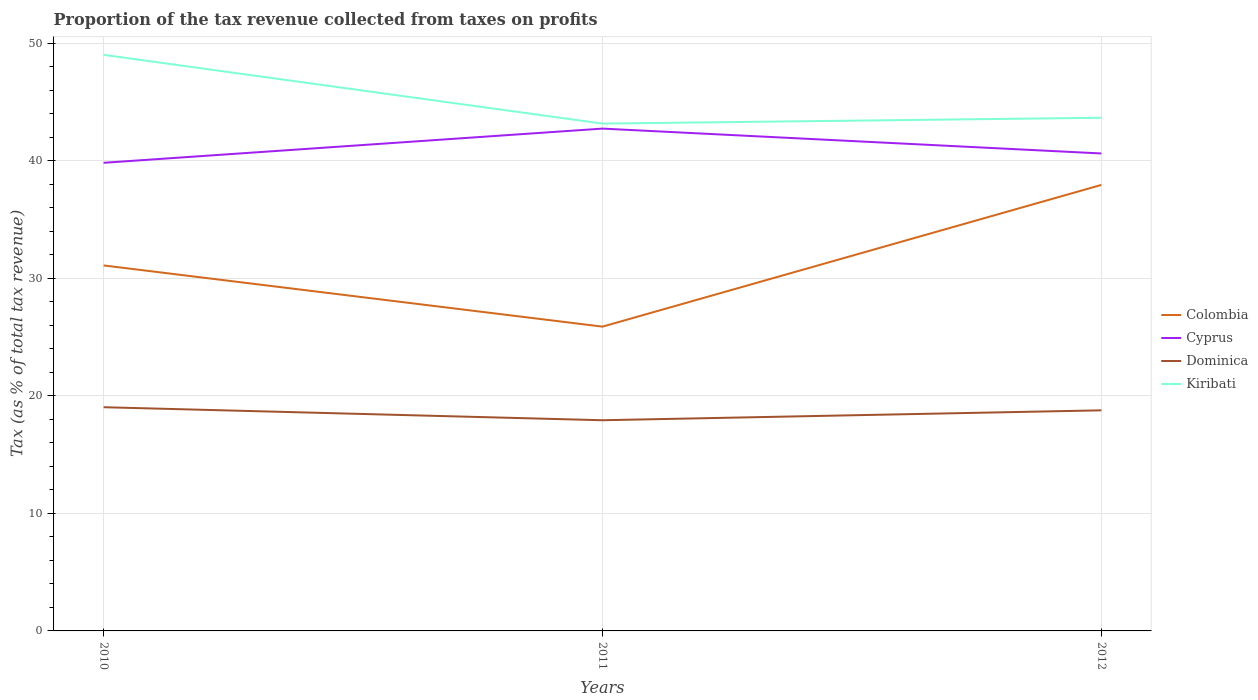Across all years, what is the maximum proportion of the tax revenue collected in Dominica?
Keep it short and to the point. 17.92. What is the total proportion of the tax revenue collected in Colombia in the graph?
Make the answer very short. -6.85. What is the difference between the highest and the second highest proportion of the tax revenue collected in Cyprus?
Give a very brief answer. 2.91. What is the difference between the highest and the lowest proportion of the tax revenue collected in Dominica?
Give a very brief answer. 2. How many years are there in the graph?
Your answer should be very brief. 3. What is the difference between two consecutive major ticks on the Y-axis?
Ensure brevity in your answer.  10. Does the graph contain any zero values?
Keep it short and to the point. No. Does the graph contain grids?
Your response must be concise. Yes. Where does the legend appear in the graph?
Keep it short and to the point. Center right. How many legend labels are there?
Your answer should be compact. 4. What is the title of the graph?
Make the answer very short. Proportion of the tax revenue collected from taxes on profits. What is the label or title of the Y-axis?
Your response must be concise. Tax (as % of total tax revenue). What is the Tax (as % of total tax revenue) of Colombia in 2010?
Offer a very short reply. 31.09. What is the Tax (as % of total tax revenue) of Cyprus in 2010?
Your response must be concise. 39.82. What is the Tax (as % of total tax revenue) in Dominica in 2010?
Your answer should be compact. 19.03. What is the Tax (as % of total tax revenue) in Kiribati in 2010?
Your response must be concise. 49. What is the Tax (as % of total tax revenue) of Colombia in 2011?
Offer a very short reply. 25.88. What is the Tax (as % of total tax revenue) of Cyprus in 2011?
Provide a short and direct response. 42.73. What is the Tax (as % of total tax revenue) in Dominica in 2011?
Offer a terse response. 17.92. What is the Tax (as % of total tax revenue) in Kiribati in 2011?
Provide a succinct answer. 43.16. What is the Tax (as % of total tax revenue) of Colombia in 2012?
Provide a short and direct response. 37.94. What is the Tax (as % of total tax revenue) of Cyprus in 2012?
Keep it short and to the point. 40.61. What is the Tax (as % of total tax revenue) in Dominica in 2012?
Keep it short and to the point. 18.76. What is the Tax (as % of total tax revenue) in Kiribati in 2012?
Your answer should be very brief. 43.65. Across all years, what is the maximum Tax (as % of total tax revenue) in Colombia?
Provide a succinct answer. 37.94. Across all years, what is the maximum Tax (as % of total tax revenue) of Cyprus?
Offer a very short reply. 42.73. Across all years, what is the maximum Tax (as % of total tax revenue) of Dominica?
Your answer should be compact. 19.03. Across all years, what is the maximum Tax (as % of total tax revenue) in Kiribati?
Provide a succinct answer. 49. Across all years, what is the minimum Tax (as % of total tax revenue) in Colombia?
Offer a very short reply. 25.88. Across all years, what is the minimum Tax (as % of total tax revenue) of Cyprus?
Offer a terse response. 39.82. Across all years, what is the minimum Tax (as % of total tax revenue) in Dominica?
Make the answer very short. 17.92. Across all years, what is the minimum Tax (as % of total tax revenue) in Kiribati?
Give a very brief answer. 43.16. What is the total Tax (as % of total tax revenue) of Colombia in the graph?
Offer a very short reply. 94.92. What is the total Tax (as % of total tax revenue) in Cyprus in the graph?
Your answer should be compact. 123.17. What is the total Tax (as % of total tax revenue) in Dominica in the graph?
Your answer should be very brief. 55.72. What is the total Tax (as % of total tax revenue) in Kiribati in the graph?
Your response must be concise. 135.81. What is the difference between the Tax (as % of total tax revenue) of Colombia in 2010 and that in 2011?
Make the answer very short. 5.21. What is the difference between the Tax (as % of total tax revenue) of Cyprus in 2010 and that in 2011?
Provide a succinct answer. -2.91. What is the difference between the Tax (as % of total tax revenue) of Dominica in 2010 and that in 2011?
Make the answer very short. 1.11. What is the difference between the Tax (as % of total tax revenue) in Kiribati in 2010 and that in 2011?
Provide a short and direct response. 5.85. What is the difference between the Tax (as % of total tax revenue) of Colombia in 2010 and that in 2012?
Offer a terse response. -6.85. What is the difference between the Tax (as % of total tax revenue) of Cyprus in 2010 and that in 2012?
Your response must be concise. -0.79. What is the difference between the Tax (as % of total tax revenue) of Dominica in 2010 and that in 2012?
Your answer should be compact. 0.27. What is the difference between the Tax (as % of total tax revenue) in Kiribati in 2010 and that in 2012?
Offer a very short reply. 5.35. What is the difference between the Tax (as % of total tax revenue) of Colombia in 2011 and that in 2012?
Provide a short and direct response. -12.06. What is the difference between the Tax (as % of total tax revenue) in Cyprus in 2011 and that in 2012?
Offer a very short reply. 2.12. What is the difference between the Tax (as % of total tax revenue) of Dominica in 2011 and that in 2012?
Your response must be concise. -0.84. What is the difference between the Tax (as % of total tax revenue) in Kiribati in 2011 and that in 2012?
Your response must be concise. -0.5. What is the difference between the Tax (as % of total tax revenue) in Colombia in 2010 and the Tax (as % of total tax revenue) in Cyprus in 2011?
Your answer should be compact. -11.64. What is the difference between the Tax (as % of total tax revenue) of Colombia in 2010 and the Tax (as % of total tax revenue) of Dominica in 2011?
Offer a terse response. 13.17. What is the difference between the Tax (as % of total tax revenue) of Colombia in 2010 and the Tax (as % of total tax revenue) of Kiribati in 2011?
Your answer should be compact. -12.07. What is the difference between the Tax (as % of total tax revenue) in Cyprus in 2010 and the Tax (as % of total tax revenue) in Dominica in 2011?
Your answer should be compact. 21.9. What is the difference between the Tax (as % of total tax revenue) of Cyprus in 2010 and the Tax (as % of total tax revenue) of Kiribati in 2011?
Give a very brief answer. -3.34. What is the difference between the Tax (as % of total tax revenue) in Dominica in 2010 and the Tax (as % of total tax revenue) in Kiribati in 2011?
Make the answer very short. -24.13. What is the difference between the Tax (as % of total tax revenue) in Colombia in 2010 and the Tax (as % of total tax revenue) in Cyprus in 2012?
Your answer should be very brief. -9.52. What is the difference between the Tax (as % of total tax revenue) of Colombia in 2010 and the Tax (as % of total tax revenue) of Dominica in 2012?
Your response must be concise. 12.33. What is the difference between the Tax (as % of total tax revenue) in Colombia in 2010 and the Tax (as % of total tax revenue) in Kiribati in 2012?
Make the answer very short. -12.56. What is the difference between the Tax (as % of total tax revenue) in Cyprus in 2010 and the Tax (as % of total tax revenue) in Dominica in 2012?
Keep it short and to the point. 21.06. What is the difference between the Tax (as % of total tax revenue) of Cyprus in 2010 and the Tax (as % of total tax revenue) of Kiribati in 2012?
Give a very brief answer. -3.83. What is the difference between the Tax (as % of total tax revenue) in Dominica in 2010 and the Tax (as % of total tax revenue) in Kiribati in 2012?
Your response must be concise. -24.62. What is the difference between the Tax (as % of total tax revenue) in Colombia in 2011 and the Tax (as % of total tax revenue) in Cyprus in 2012?
Provide a short and direct response. -14.73. What is the difference between the Tax (as % of total tax revenue) in Colombia in 2011 and the Tax (as % of total tax revenue) in Dominica in 2012?
Your response must be concise. 7.12. What is the difference between the Tax (as % of total tax revenue) in Colombia in 2011 and the Tax (as % of total tax revenue) in Kiribati in 2012?
Your response must be concise. -17.77. What is the difference between the Tax (as % of total tax revenue) of Cyprus in 2011 and the Tax (as % of total tax revenue) of Dominica in 2012?
Your answer should be compact. 23.97. What is the difference between the Tax (as % of total tax revenue) of Cyprus in 2011 and the Tax (as % of total tax revenue) of Kiribati in 2012?
Ensure brevity in your answer.  -0.92. What is the difference between the Tax (as % of total tax revenue) in Dominica in 2011 and the Tax (as % of total tax revenue) in Kiribati in 2012?
Ensure brevity in your answer.  -25.73. What is the average Tax (as % of total tax revenue) in Colombia per year?
Keep it short and to the point. 31.64. What is the average Tax (as % of total tax revenue) in Cyprus per year?
Your answer should be very brief. 41.06. What is the average Tax (as % of total tax revenue) in Dominica per year?
Give a very brief answer. 18.57. What is the average Tax (as % of total tax revenue) of Kiribati per year?
Your answer should be very brief. 45.27. In the year 2010, what is the difference between the Tax (as % of total tax revenue) in Colombia and Tax (as % of total tax revenue) in Cyprus?
Your answer should be very brief. -8.73. In the year 2010, what is the difference between the Tax (as % of total tax revenue) in Colombia and Tax (as % of total tax revenue) in Dominica?
Your answer should be compact. 12.06. In the year 2010, what is the difference between the Tax (as % of total tax revenue) in Colombia and Tax (as % of total tax revenue) in Kiribati?
Your answer should be compact. -17.91. In the year 2010, what is the difference between the Tax (as % of total tax revenue) of Cyprus and Tax (as % of total tax revenue) of Dominica?
Keep it short and to the point. 20.79. In the year 2010, what is the difference between the Tax (as % of total tax revenue) of Cyprus and Tax (as % of total tax revenue) of Kiribati?
Offer a terse response. -9.18. In the year 2010, what is the difference between the Tax (as % of total tax revenue) of Dominica and Tax (as % of total tax revenue) of Kiribati?
Offer a terse response. -29.97. In the year 2011, what is the difference between the Tax (as % of total tax revenue) of Colombia and Tax (as % of total tax revenue) of Cyprus?
Keep it short and to the point. -16.85. In the year 2011, what is the difference between the Tax (as % of total tax revenue) of Colombia and Tax (as % of total tax revenue) of Dominica?
Provide a short and direct response. 7.96. In the year 2011, what is the difference between the Tax (as % of total tax revenue) of Colombia and Tax (as % of total tax revenue) of Kiribati?
Ensure brevity in your answer.  -17.27. In the year 2011, what is the difference between the Tax (as % of total tax revenue) of Cyprus and Tax (as % of total tax revenue) of Dominica?
Keep it short and to the point. 24.81. In the year 2011, what is the difference between the Tax (as % of total tax revenue) of Cyprus and Tax (as % of total tax revenue) of Kiribati?
Offer a very short reply. -0.43. In the year 2011, what is the difference between the Tax (as % of total tax revenue) of Dominica and Tax (as % of total tax revenue) of Kiribati?
Offer a terse response. -25.23. In the year 2012, what is the difference between the Tax (as % of total tax revenue) of Colombia and Tax (as % of total tax revenue) of Cyprus?
Offer a terse response. -2.67. In the year 2012, what is the difference between the Tax (as % of total tax revenue) in Colombia and Tax (as % of total tax revenue) in Dominica?
Your answer should be compact. 19.18. In the year 2012, what is the difference between the Tax (as % of total tax revenue) in Colombia and Tax (as % of total tax revenue) in Kiribati?
Your answer should be compact. -5.71. In the year 2012, what is the difference between the Tax (as % of total tax revenue) of Cyprus and Tax (as % of total tax revenue) of Dominica?
Ensure brevity in your answer.  21.85. In the year 2012, what is the difference between the Tax (as % of total tax revenue) of Cyprus and Tax (as % of total tax revenue) of Kiribati?
Your response must be concise. -3.04. In the year 2012, what is the difference between the Tax (as % of total tax revenue) in Dominica and Tax (as % of total tax revenue) in Kiribati?
Provide a short and direct response. -24.89. What is the ratio of the Tax (as % of total tax revenue) of Colombia in 2010 to that in 2011?
Your response must be concise. 1.2. What is the ratio of the Tax (as % of total tax revenue) of Cyprus in 2010 to that in 2011?
Provide a short and direct response. 0.93. What is the ratio of the Tax (as % of total tax revenue) in Dominica in 2010 to that in 2011?
Your response must be concise. 1.06. What is the ratio of the Tax (as % of total tax revenue) in Kiribati in 2010 to that in 2011?
Offer a terse response. 1.14. What is the ratio of the Tax (as % of total tax revenue) of Colombia in 2010 to that in 2012?
Ensure brevity in your answer.  0.82. What is the ratio of the Tax (as % of total tax revenue) of Cyprus in 2010 to that in 2012?
Offer a very short reply. 0.98. What is the ratio of the Tax (as % of total tax revenue) in Dominica in 2010 to that in 2012?
Give a very brief answer. 1.01. What is the ratio of the Tax (as % of total tax revenue) of Kiribati in 2010 to that in 2012?
Give a very brief answer. 1.12. What is the ratio of the Tax (as % of total tax revenue) in Colombia in 2011 to that in 2012?
Offer a very short reply. 0.68. What is the ratio of the Tax (as % of total tax revenue) of Cyprus in 2011 to that in 2012?
Provide a succinct answer. 1.05. What is the ratio of the Tax (as % of total tax revenue) of Dominica in 2011 to that in 2012?
Make the answer very short. 0.96. What is the ratio of the Tax (as % of total tax revenue) in Kiribati in 2011 to that in 2012?
Give a very brief answer. 0.99. What is the difference between the highest and the second highest Tax (as % of total tax revenue) of Colombia?
Provide a succinct answer. 6.85. What is the difference between the highest and the second highest Tax (as % of total tax revenue) of Cyprus?
Your answer should be very brief. 2.12. What is the difference between the highest and the second highest Tax (as % of total tax revenue) of Dominica?
Offer a very short reply. 0.27. What is the difference between the highest and the second highest Tax (as % of total tax revenue) in Kiribati?
Your answer should be very brief. 5.35. What is the difference between the highest and the lowest Tax (as % of total tax revenue) of Colombia?
Offer a very short reply. 12.06. What is the difference between the highest and the lowest Tax (as % of total tax revenue) of Cyprus?
Your answer should be very brief. 2.91. What is the difference between the highest and the lowest Tax (as % of total tax revenue) in Dominica?
Keep it short and to the point. 1.11. What is the difference between the highest and the lowest Tax (as % of total tax revenue) of Kiribati?
Offer a terse response. 5.85. 